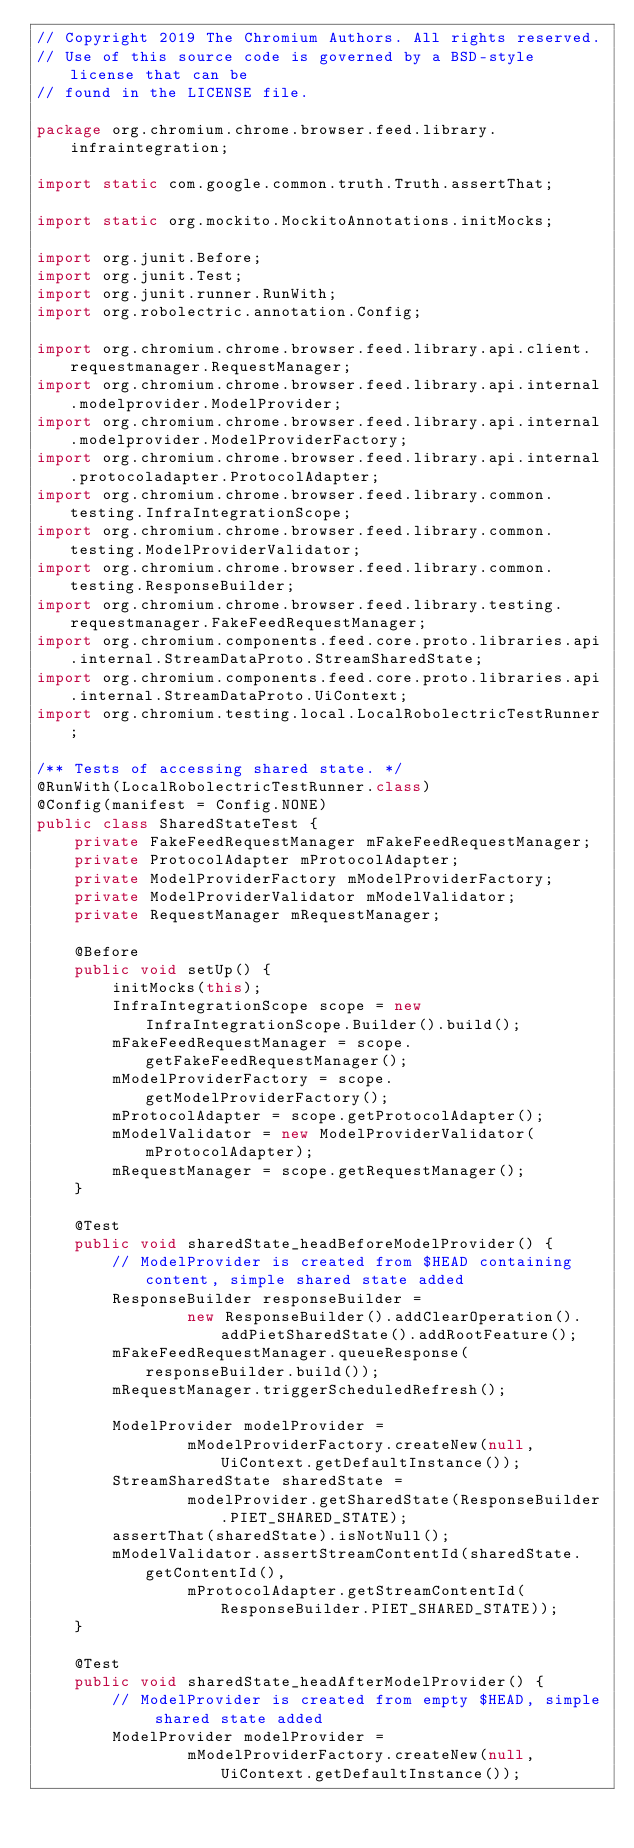<code> <loc_0><loc_0><loc_500><loc_500><_Java_>// Copyright 2019 The Chromium Authors. All rights reserved.
// Use of this source code is governed by a BSD-style license that can be
// found in the LICENSE file.

package org.chromium.chrome.browser.feed.library.infraintegration;

import static com.google.common.truth.Truth.assertThat;

import static org.mockito.MockitoAnnotations.initMocks;

import org.junit.Before;
import org.junit.Test;
import org.junit.runner.RunWith;
import org.robolectric.annotation.Config;

import org.chromium.chrome.browser.feed.library.api.client.requestmanager.RequestManager;
import org.chromium.chrome.browser.feed.library.api.internal.modelprovider.ModelProvider;
import org.chromium.chrome.browser.feed.library.api.internal.modelprovider.ModelProviderFactory;
import org.chromium.chrome.browser.feed.library.api.internal.protocoladapter.ProtocolAdapter;
import org.chromium.chrome.browser.feed.library.common.testing.InfraIntegrationScope;
import org.chromium.chrome.browser.feed.library.common.testing.ModelProviderValidator;
import org.chromium.chrome.browser.feed.library.common.testing.ResponseBuilder;
import org.chromium.chrome.browser.feed.library.testing.requestmanager.FakeFeedRequestManager;
import org.chromium.components.feed.core.proto.libraries.api.internal.StreamDataProto.StreamSharedState;
import org.chromium.components.feed.core.proto.libraries.api.internal.StreamDataProto.UiContext;
import org.chromium.testing.local.LocalRobolectricTestRunner;

/** Tests of accessing shared state. */
@RunWith(LocalRobolectricTestRunner.class)
@Config(manifest = Config.NONE)
public class SharedStateTest {
    private FakeFeedRequestManager mFakeFeedRequestManager;
    private ProtocolAdapter mProtocolAdapter;
    private ModelProviderFactory mModelProviderFactory;
    private ModelProviderValidator mModelValidator;
    private RequestManager mRequestManager;

    @Before
    public void setUp() {
        initMocks(this);
        InfraIntegrationScope scope = new InfraIntegrationScope.Builder().build();
        mFakeFeedRequestManager = scope.getFakeFeedRequestManager();
        mModelProviderFactory = scope.getModelProviderFactory();
        mProtocolAdapter = scope.getProtocolAdapter();
        mModelValidator = new ModelProviderValidator(mProtocolAdapter);
        mRequestManager = scope.getRequestManager();
    }

    @Test
    public void sharedState_headBeforeModelProvider() {
        // ModelProvider is created from $HEAD containing content, simple shared state added
        ResponseBuilder responseBuilder =
                new ResponseBuilder().addClearOperation().addPietSharedState().addRootFeature();
        mFakeFeedRequestManager.queueResponse(responseBuilder.build());
        mRequestManager.triggerScheduledRefresh();

        ModelProvider modelProvider =
                mModelProviderFactory.createNew(null, UiContext.getDefaultInstance());
        StreamSharedState sharedState =
                modelProvider.getSharedState(ResponseBuilder.PIET_SHARED_STATE);
        assertThat(sharedState).isNotNull();
        mModelValidator.assertStreamContentId(sharedState.getContentId(),
                mProtocolAdapter.getStreamContentId(ResponseBuilder.PIET_SHARED_STATE));
    }

    @Test
    public void sharedState_headAfterModelProvider() {
        // ModelProvider is created from empty $HEAD, simple shared state added
        ModelProvider modelProvider =
                mModelProviderFactory.createNew(null, UiContext.getDefaultInstance());</code> 